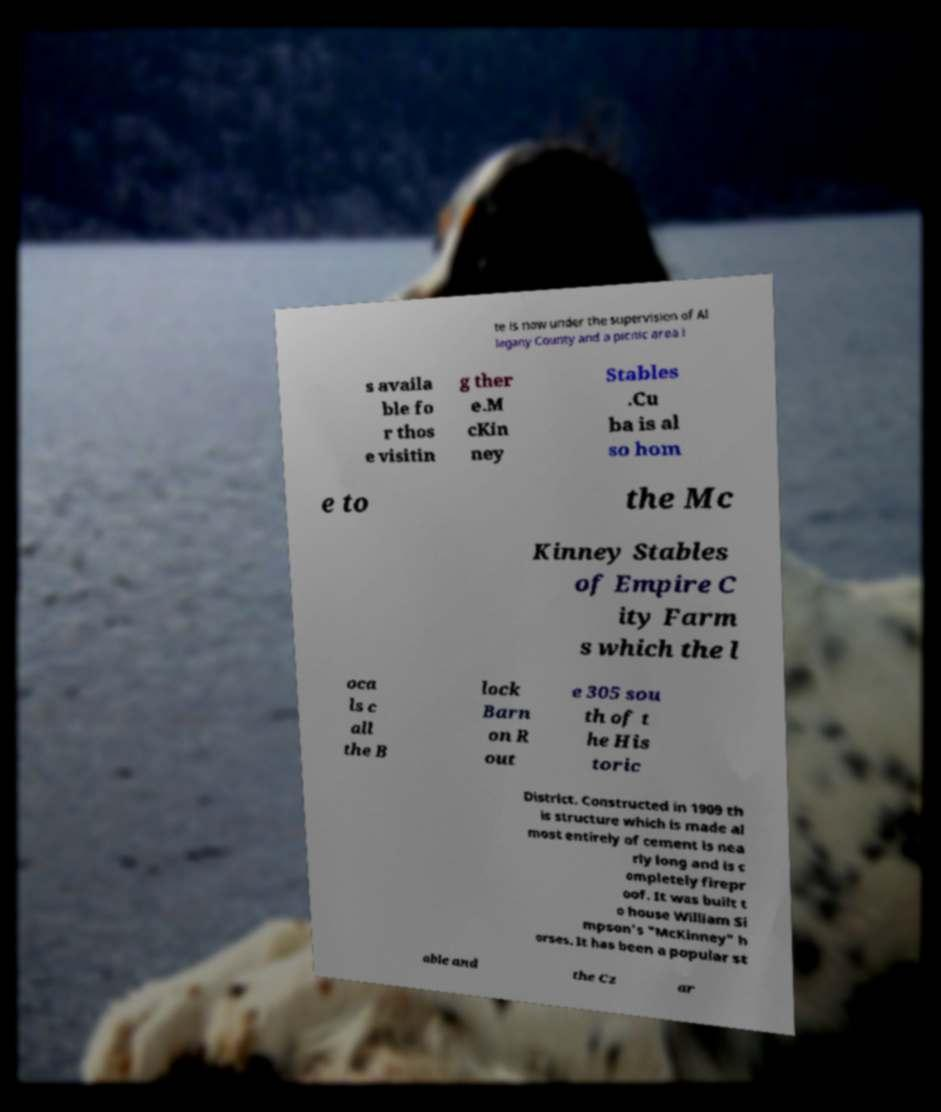For documentation purposes, I need the text within this image transcribed. Could you provide that? te is now under the supervision of Al legany County and a picnic area i s availa ble fo r thos e visitin g ther e.M cKin ney Stables .Cu ba is al so hom e to the Mc Kinney Stables of Empire C ity Farm s which the l oca ls c all the B lock Barn on R out e 305 sou th of t he His toric District. Constructed in 1909 th is structure which is made al most entirely of cement is nea rly long and is c ompletely firepr oof. It was built t o house William Si mpson's "McKinney" h orses. It has been a popular st able and the Cz ar 